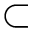Convert formula to latex. <formula><loc_0><loc_0><loc_500><loc_500>\subset</formula> 